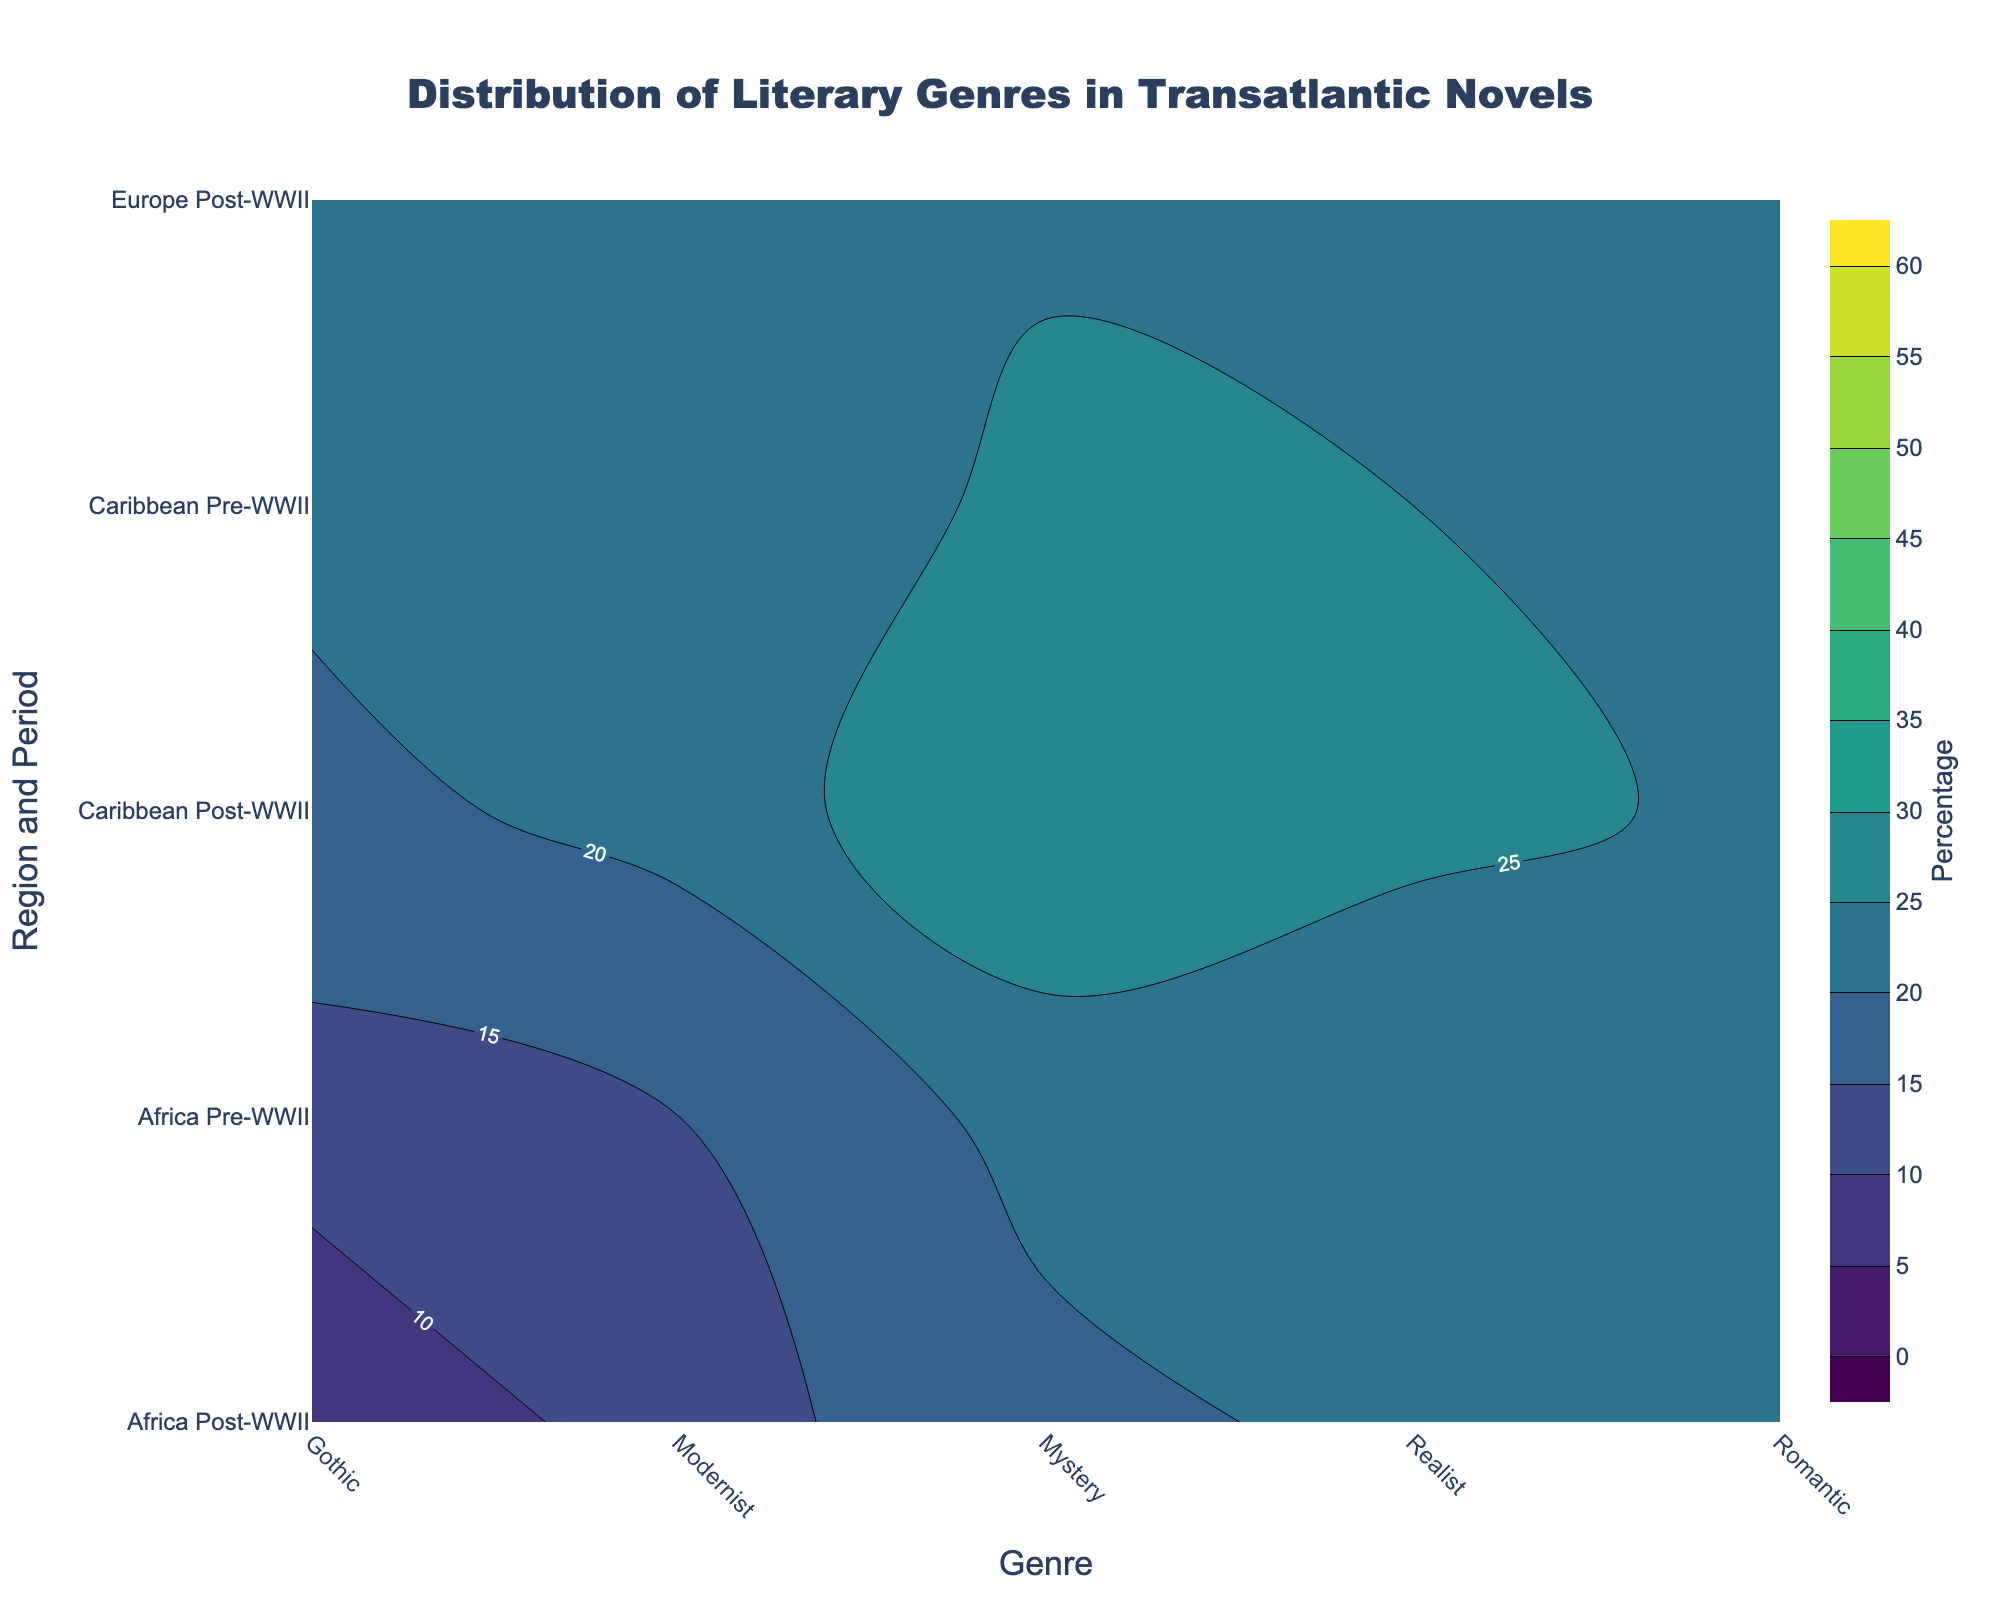What's the most dominant genre in North America post-WWII? To find the most dominant genre in North America post-WWII, look at the contour plot section corresponding to North America post-WWII. The highest labeled percentage is 40% for Mystery.
Answer: Mystery What genre had a significant drop in percentage in Europe from pre-WWII to post-WWII? Compare the contour plot sections for Europe pre-WWII and post-WWII. Gothic had a drop from 10% to 5%.
Answer: Gothic Which region shows the biggest increase in the Modernist genre from pre-WWII to post-WWII? Examine the contour plots of all regions for pre-WWII and post-WWII. Africa shows an increase from 10% to 15% in the Modernist genre.
Answer: Africa How does the proportion of Realist novels in the Caribbean change from pre-WWII to post-WWII? Look at the contour plot sections for the Caribbean pre-WWII and post-WWII. The Realist genre decreases from 20% to 15%.
Answer: Decreases Which genre in Africa post-WWII has the highest percentage? Examine the contour plot for Africa post-WWII. The highest percentage labeled is 30% for Mystery.
Answer: Mystery What's the average percentage of the Romantic genre across all regions post-WWII? Calculate the average by adding the percentages of Romantic genre in all regions post-WWII: (5% + 5% + 55% + 25%) / 4 = 22.5%.
Answer: 22.5% Which region had the highest percentage of Romantic novels pre-WWII? Check the contour plot sections for all regions pre-WWII. The highest percentage is 45% in the Caribbean.
Answer: Caribbean What’s the trend in Gothic novels from pre-WWII to post-WWII in North America? Compare the percentages for Gothic novels in North America pre-WWII to post-WWII. The percentage decreases from 15% to 10%.
Answer: Decreases In which region did Mystery novels become more prominent post-WWII? Compare the Mystery genre pre-WWII and post-WWII across all regions. Both North America and Europe show an increase, but examine the specific numbers: North America increased by 20% and Europe by 15%. Thus, North America has a greater increase.
Answer: North America What's the least prominent genre in Europe pre-WWII? Look at the contour plot section for Europe pre-WWII. The lowest percentage labeled is 10% for Gothic.
Answer: Gothic 